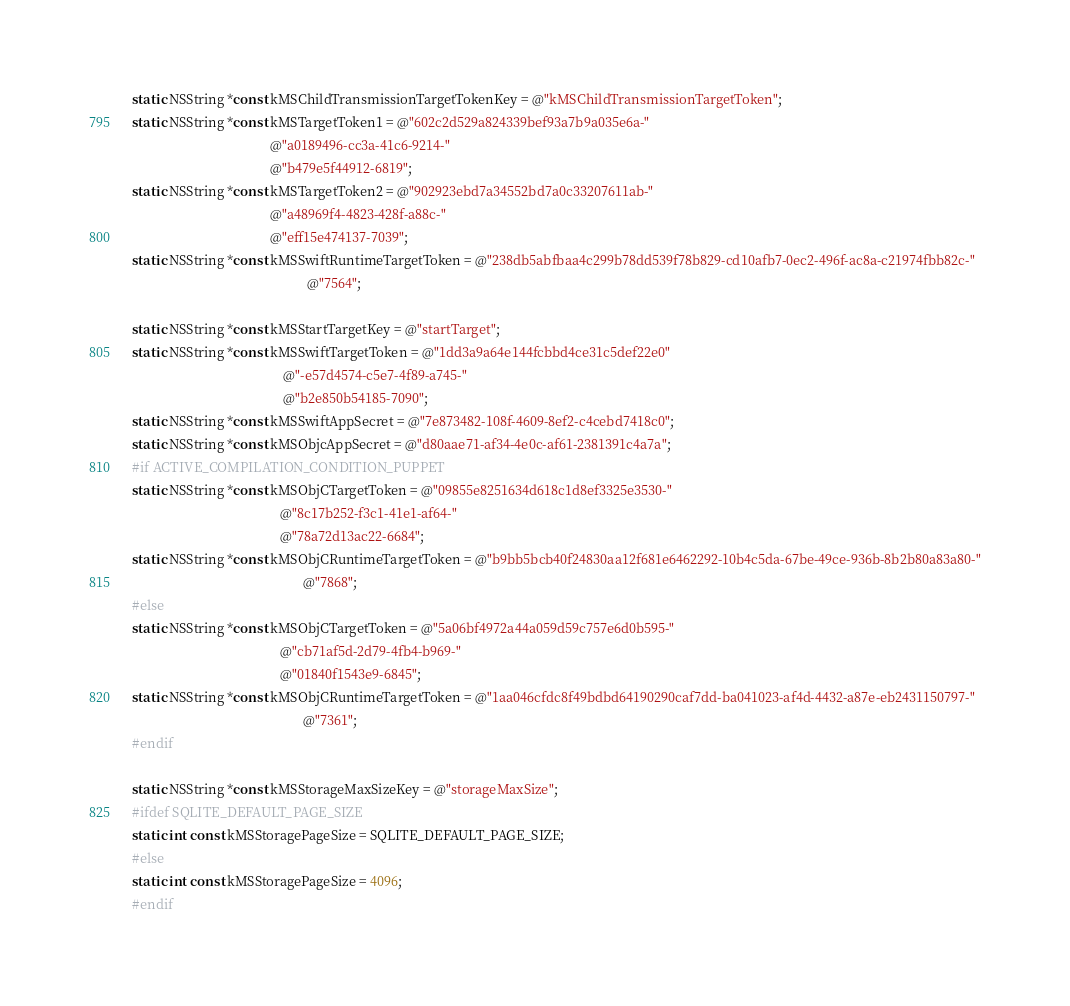Convert code to text. <code><loc_0><loc_0><loc_500><loc_500><_C_>static NSString *const kMSChildTransmissionTargetTokenKey = @"kMSChildTransmissionTargetToken";
static NSString *const kMSTargetToken1 = @"602c2d529a824339bef93a7b9a035e6a-"
                                         @"a0189496-cc3a-41c6-9214-"
                                         @"b479e5f44912-6819";
static NSString *const kMSTargetToken2 = @"902923ebd7a34552bd7a0c33207611ab-"
                                         @"a48969f4-4823-428f-a88c-"
                                         @"eff15e474137-7039";
static NSString *const kMSSwiftRuntimeTargetToken = @"238db5abfbaa4c299b78dd539f78b829-cd10afb7-0ec2-496f-ac8a-c21974fbb82c-"
                                                    @"7564";

static NSString *const kMSStartTargetKey = @"startTarget";
static NSString *const kMSSwiftTargetToken = @"1dd3a9a64e144fcbbd4ce31c5def22e0"
                                             @"-e57d4574-c5e7-4f89-a745-"
                                             @"b2e850b54185-7090";
static NSString *const kMSSwiftAppSecret = @"7e873482-108f-4609-8ef2-c4cebd7418c0";
static NSString *const kMSObjcAppSecret = @"d80aae71-af34-4e0c-af61-2381391c4a7a";
#if ACTIVE_COMPILATION_CONDITION_PUPPET
static NSString *const kMSObjCTargetToken = @"09855e8251634d618c1d8ef3325e3530-"
                                            @"8c17b252-f3c1-41e1-af64-"
                                            @"78a72d13ac22-6684";
static NSString *const kMSObjCRuntimeTargetToken = @"b9bb5bcb40f24830aa12f681e6462292-10b4c5da-67be-49ce-936b-8b2b80a83a80-"
                                                   @"7868";
#else
static NSString *const kMSObjCTargetToken = @"5a06bf4972a44a059d59c757e6d0b595-"
                                            @"cb71af5d-2d79-4fb4-b969-"
                                            @"01840f1543e9-6845";
static NSString *const kMSObjCRuntimeTargetToken = @"1aa046cfdc8f49bdbd64190290caf7dd-ba041023-af4d-4432-a87e-eb2431150797-"
                                                   @"7361";
#endif

static NSString *const kMSStorageMaxSizeKey = @"storageMaxSize";
#ifdef SQLITE_DEFAULT_PAGE_SIZE
static int const kMSStoragePageSize = SQLITE_DEFAULT_PAGE_SIZE;
#else
static int const kMSStoragePageSize = 4096;
#endif
</code> 